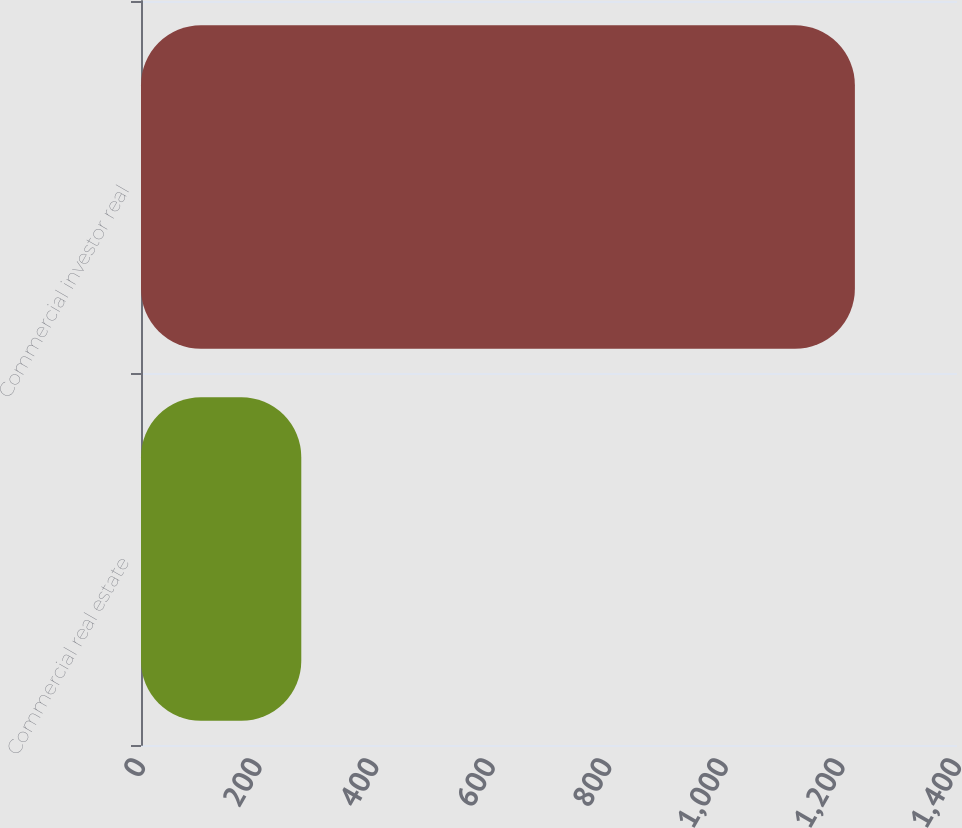<chart> <loc_0><loc_0><loc_500><loc_500><bar_chart><fcel>Commercial real estate<fcel>Commercial investor real<nl><fcel>275<fcel>1224.8<nl></chart> 